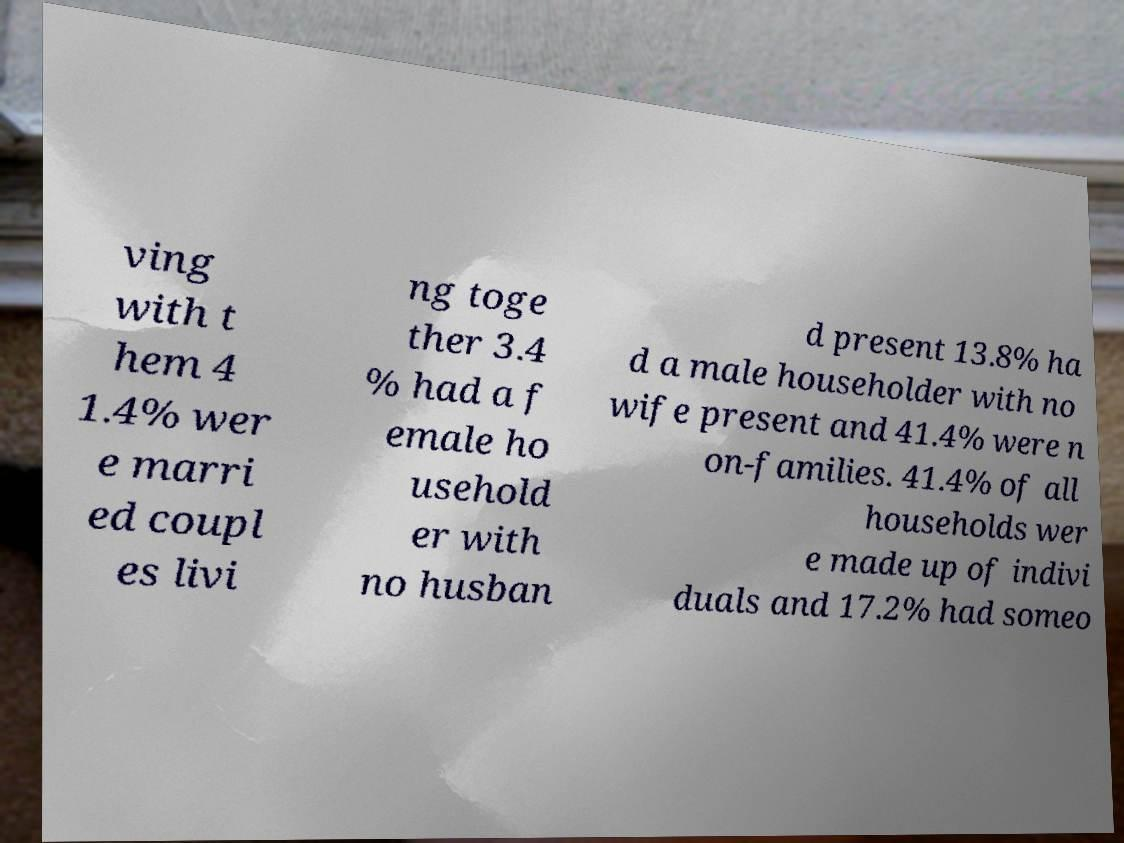Can you accurately transcribe the text from the provided image for me? ving with t hem 4 1.4% wer e marri ed coupl es livi ng toge ther 3.4 % had a f emale ho usehold er with no husban d present 13.8% ha d a male householder with no wife present and 41.4% were n on-families. 41.4% of all households wer e made up of indivi duals and 17.2% had someo 